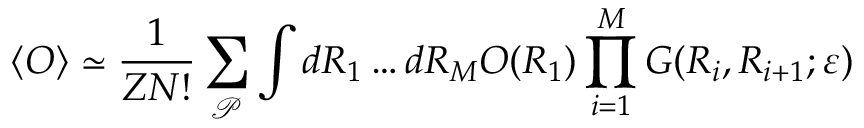<formula> <loc_0><loc_0><loc_500><loc_500>\langle O \rangle \simeq \frac { 1 } { Z N ! } \sum _ { \mathcal { P } } \int d R _ { 1 } \dots d R _ { M } O ( R _ { 1 } ) \prod _ { i = 1 } ^ { M } G ( R _ { i } , R _ { i + 1 } ; \varepsilon )</formula> 